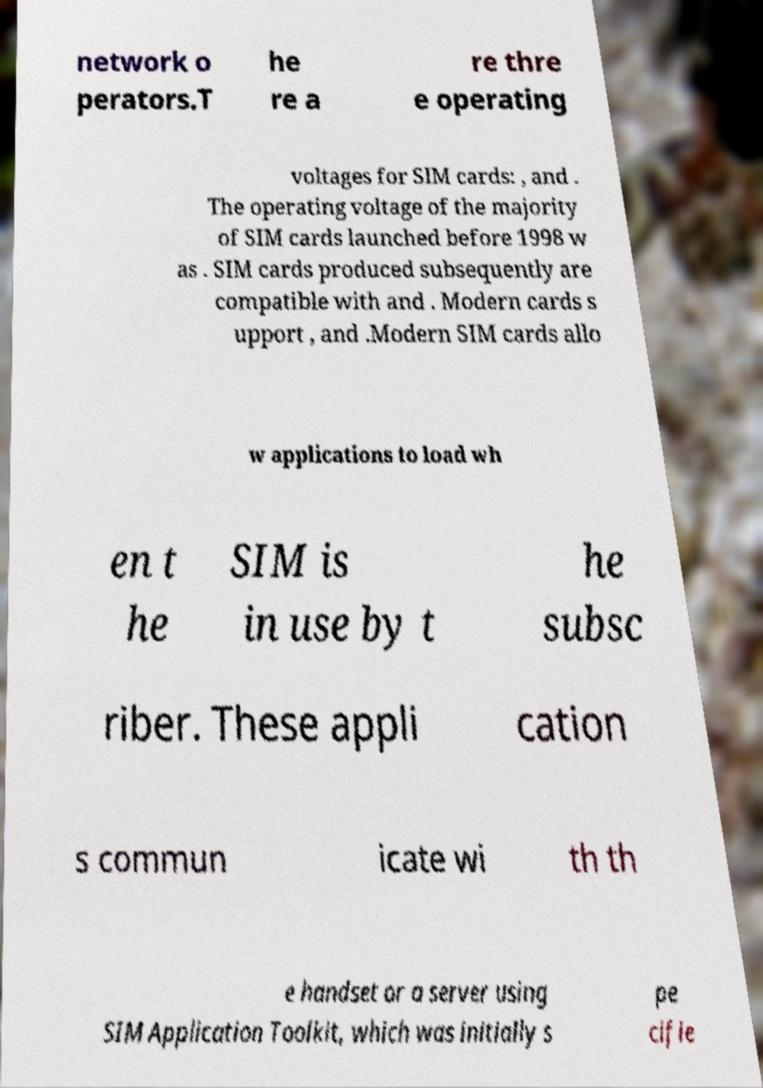Can you accurately transcribe the text from the provided image for me? network o perators.T he re a re thre e operating voltages for SIM cards: , and . The operating voltage of the majority of SIM cards launched before 1998 w as . SIM cards produced subsequently are compatible with and . Modern cards s upport , and .Modern SIM cards allo w applications to load wh en t he SIM is in use by t he subsc riber. These appli cation s commun icate wi th th e handset or a server using SIM Application Toolkit, which was initially s pe cifie 